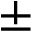<formula> <loc_0><loc_0><loc_500><loc_500>\pm</formula> 